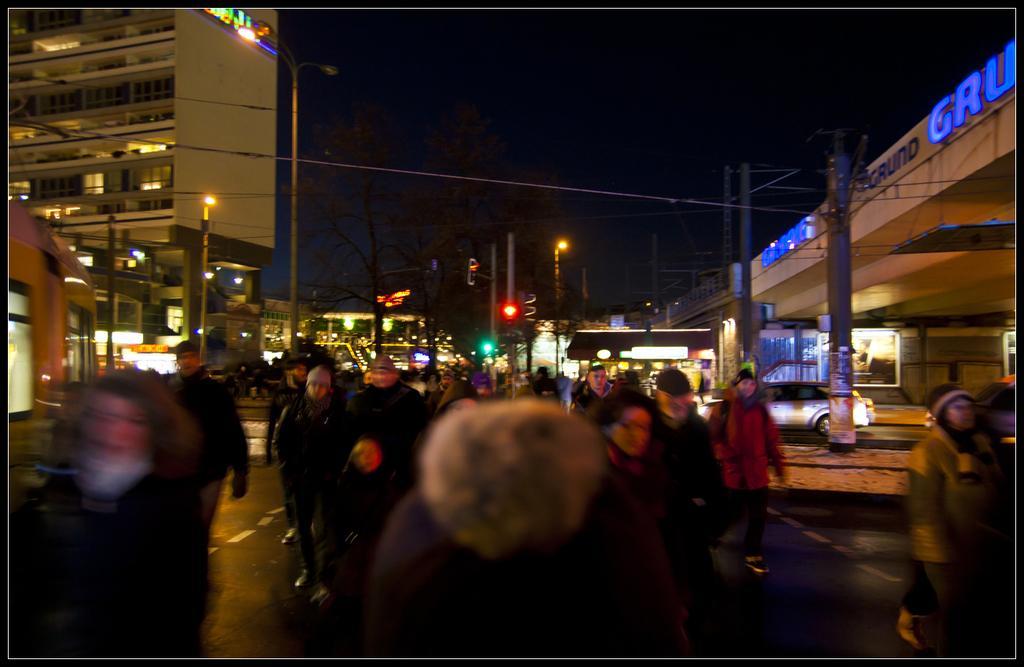Can you describe this image briefly? In this image, at the bottom there are people, they are walking. In the middle there are vehicles, buildings, street lights, poles, trees, cables, text, sky. 